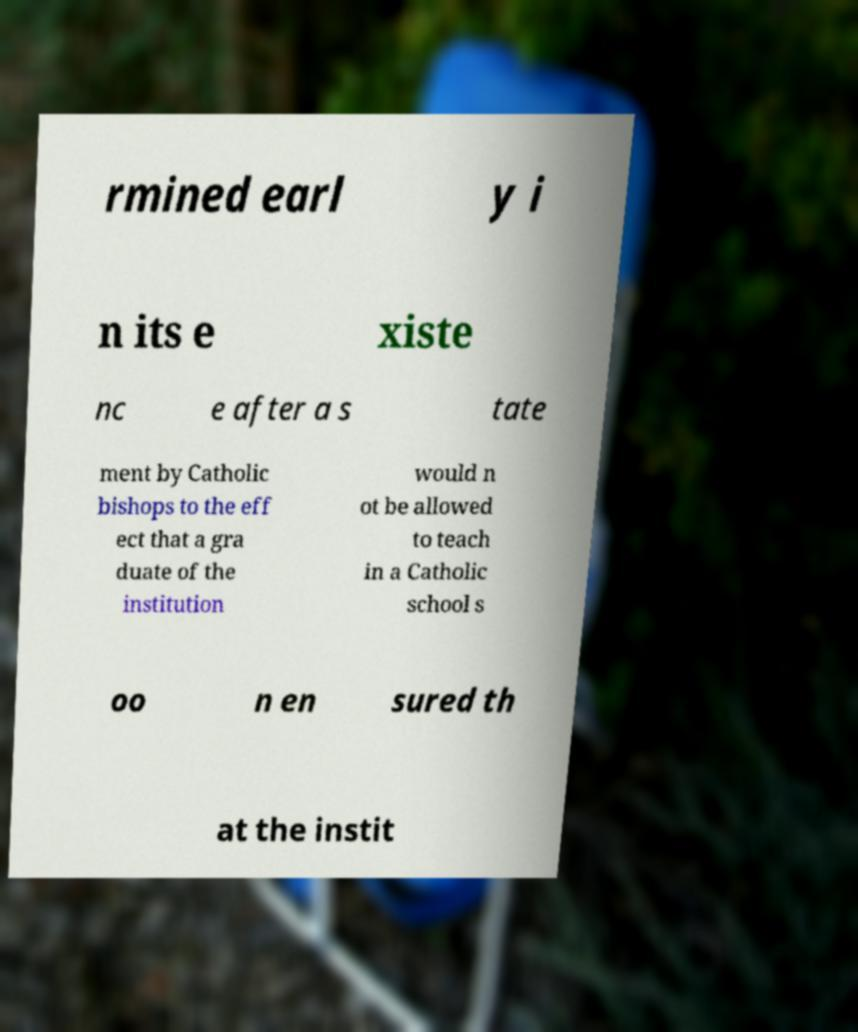Could you assist in decoding the text presented in this image and type it out clearly? rmined earl y i n its e xiste nc e after a s tate ment by Catholic bishops to the eff ect that a gra duate of the institution would n ot be allowed to teach in a Catholic school s oo n en sured th at the instit 